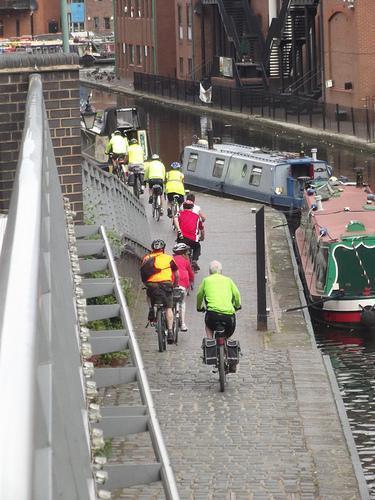How many people are riding bikes?
Give a very brief answer. 9. 